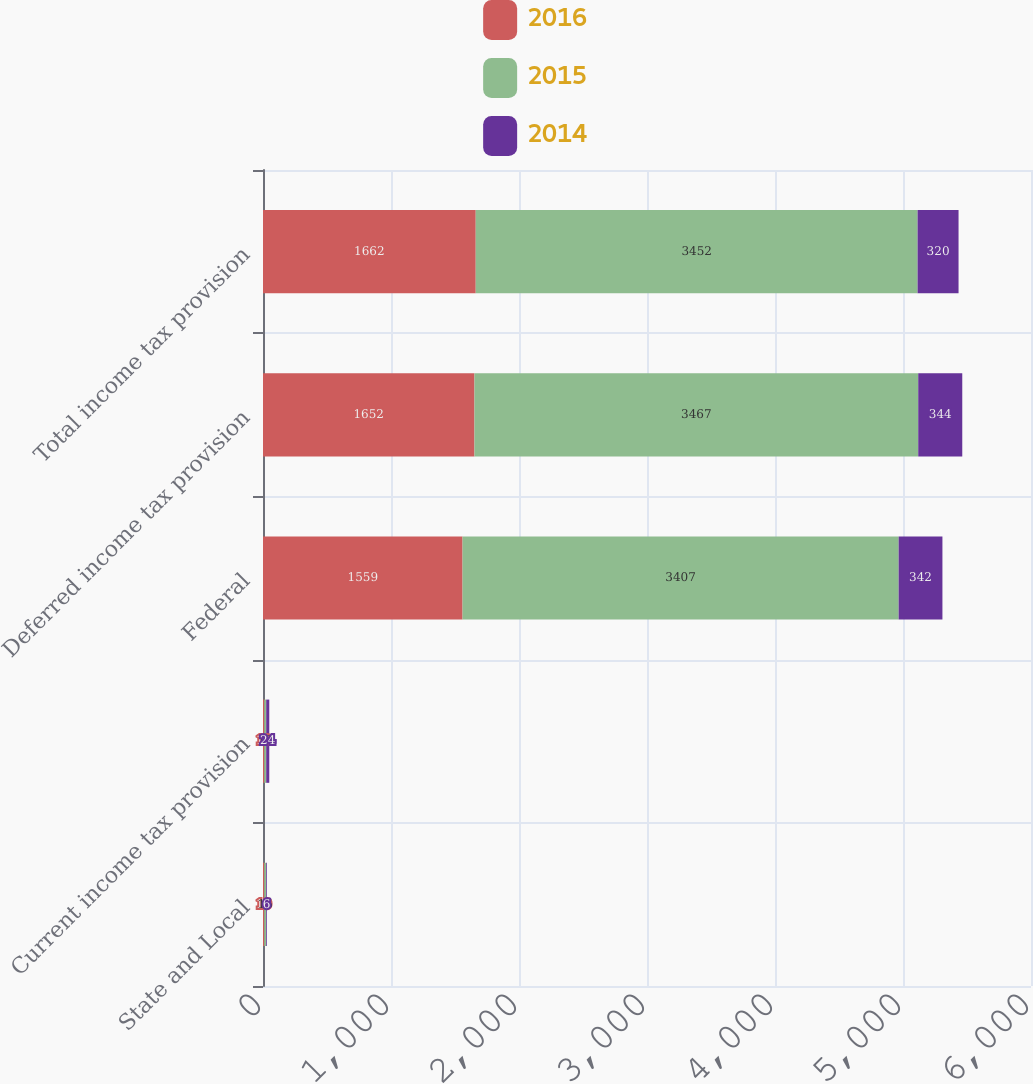Convert chart. <chart><loc_0><loc_0><loc_500><loc_500><stacked_bar_chart><ecel><fcel>State and Local<fcel>Current income tax provision<fcel>Federal<fcel>Deferred income tax provision<fcel>Total income tax provision<nl><fcel>2016<fcel>10<fcel>10<fcel>1559<fcel>1652<fcel>1662<nl><fcel>2015<fcel>15<fcel>15<fcel>3407<fcel>3467<fcel>3452<nl><fcel>2014<fcel>6<fcel>24<fcel>342<fcel>344<fcel>320<nl></chart> 